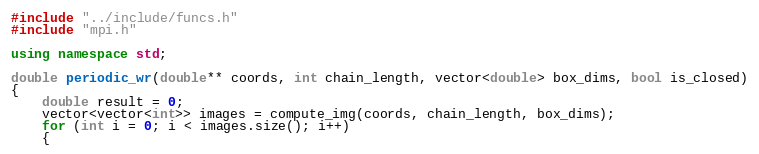Convert code to text. <code><loc_0><loc_0><loc_500><loc_500><_C++_>#include "../include/funcs.h"
#include "mpi.h"

using namespace std;

double periodic_wr(double** coords, int chain_length, vector<double> box_dims, bool is_closed)
{
	double result = 0;
	vector<vector<int>> images = compute_img(coords, chain_length, box_dims);
	for (int i = 0; i < images.size(); i++)
	{</code> 